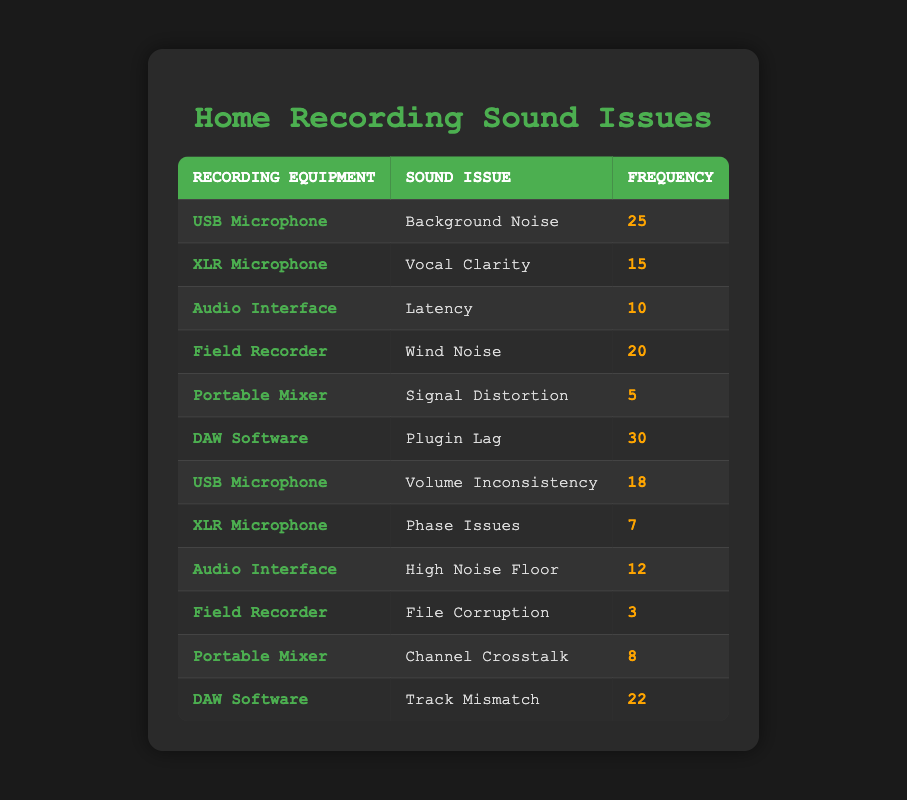What sound issue occurs most frequently with DAW Software? The row related to DAW Software shows two sound issues: Plugin Lag with a frequency of 30 and Track Mismatch with a frequency of 22. Plugin Lag has the higher frequency of the two at 30.
Answer: Plugin Lag What is the frequency of Background Noise when using a USB Microphone? The row corresponding to USB Microphone lists Background Noise with a frequency of 25 directly in the table.
Answer: 25 Which recording equipment has the highest total frequency of sound issues? I will sum the frequencies for each recording equipment: USB Microphone: 25 + 18 = 43; XLR Microphone: 15 + 7 = 22; Audio Interface: 10 + 12 = 22; Field Recorder: 20 + 3 = 23; Portable Mixer: 5 + 8 = 13; DAW Software: 30 + 22 = 52. The highest total frequency is 52 for DAW Software.
Answer: DAW Software Is there a sound issue related to File Corruption with Field Recorder? Yes, according to the table, Field Recorder has a frequency of 3 mentioned for the sound issue File Corruption.
Answer: Yes How many sound issues are recorded for the Portable Mixer? In the table, Portable Mixer has two entries: Signal Distortion with a frequency of 5 and Channel Crosstalk with a frequency of 8. Hence, there are two sound issues listed.
Answer: 2 